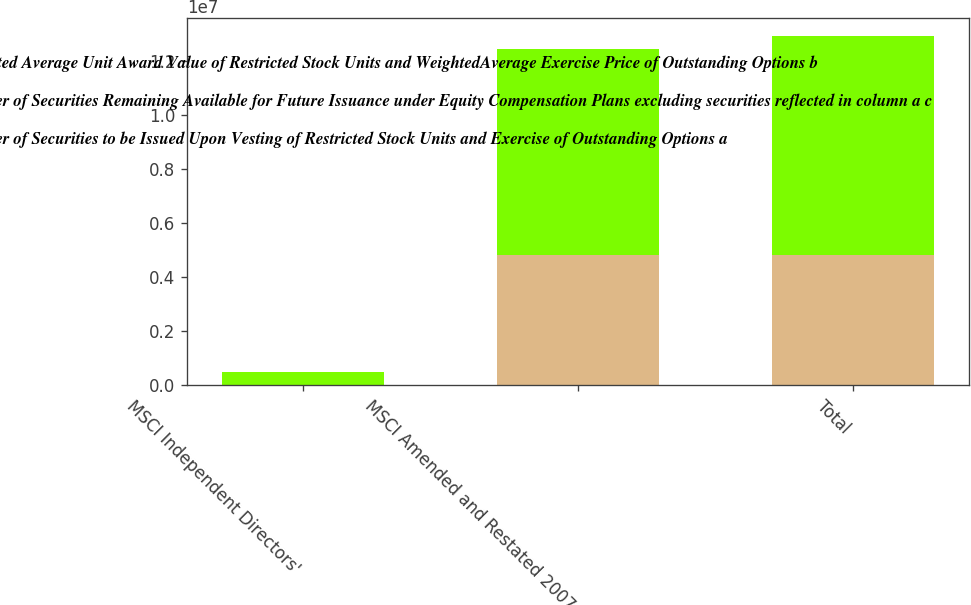Convert chart. <chart><loc_0><loc_0><loc_500><loc_500><stacked_bar_chart><ecel><fcel>MSCI Independent Directors'<fcel>MSCI Amended and Restated 2007<fcel>Total<nl><fcel>Weighted Average Unit Award Value of Restricted Stock Units and WeightedAverage Exercise Price of Outstanding Options b<fcel>5358<fcel>4.81966e+06<fcel>4.82502e+06<nl><fcel>Number of Securities Remaining Available for Future Issuance under Equity Compensation Plans excluding securities reflected in column a c<fcel>27.98<fcel>18<fcel>18<nl><fcel>Number of Securities to be Issued Upon Vesting of Restricted Stock Units and Exercise of Outstanding Options a<fcel>465186<fcel>7.63847e+06<fcel>8.10365e+06<nl></chart> 